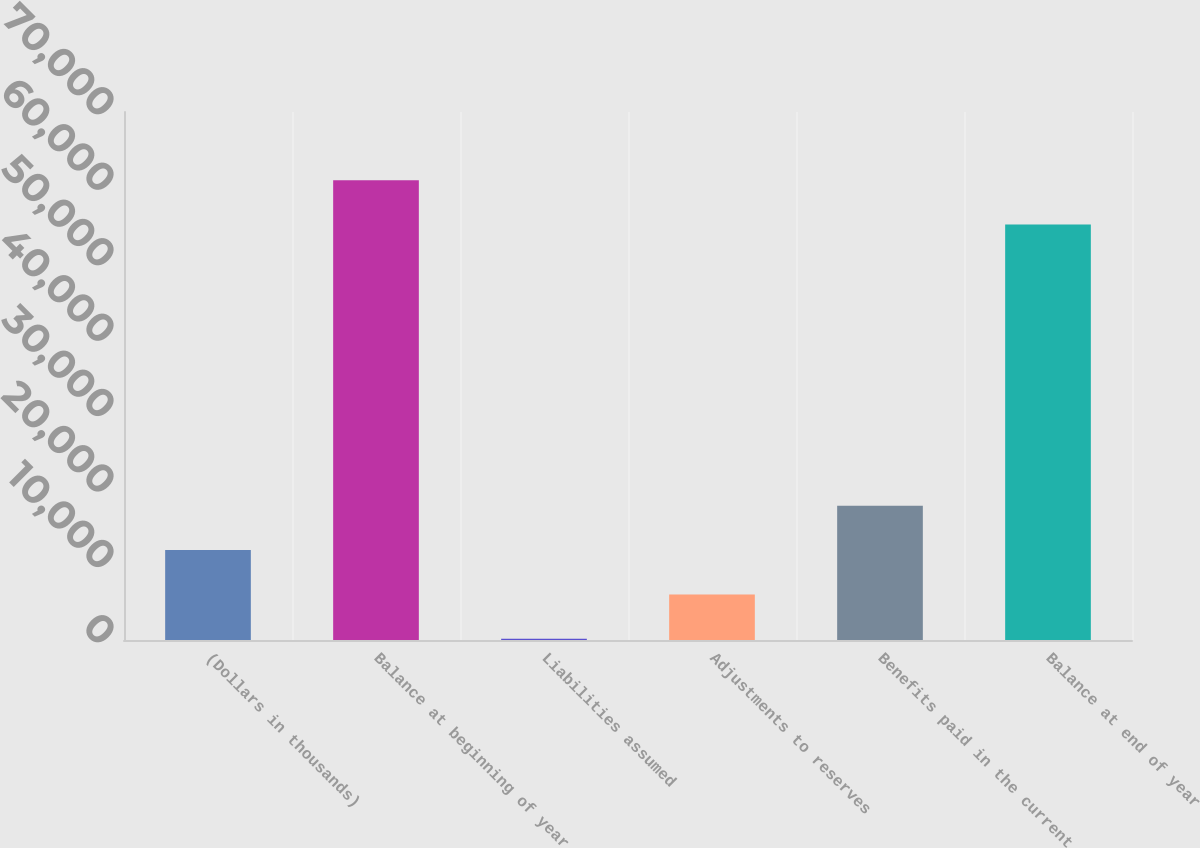Convert chart. <chart><loc_0><loc_0><loc_500><loc_500><bar_chart><fcel>(Dollars in thousands)<fcel>Balance at beginning of year<fcel>Liabilities assumed<fcel>Adjustments to reserves<fcel>Benefits paid in the current<fcel>Balance at end of year<nl><fcel>11922<fcel>60947.5<fcel>175<fcel>6048.5<fcel>17795.5<fcel>55074<nl></chart> 